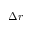Convert formula to latex. <formula><loc_0><loc_0><loc_500><loc_500>\Delta r</formula> 